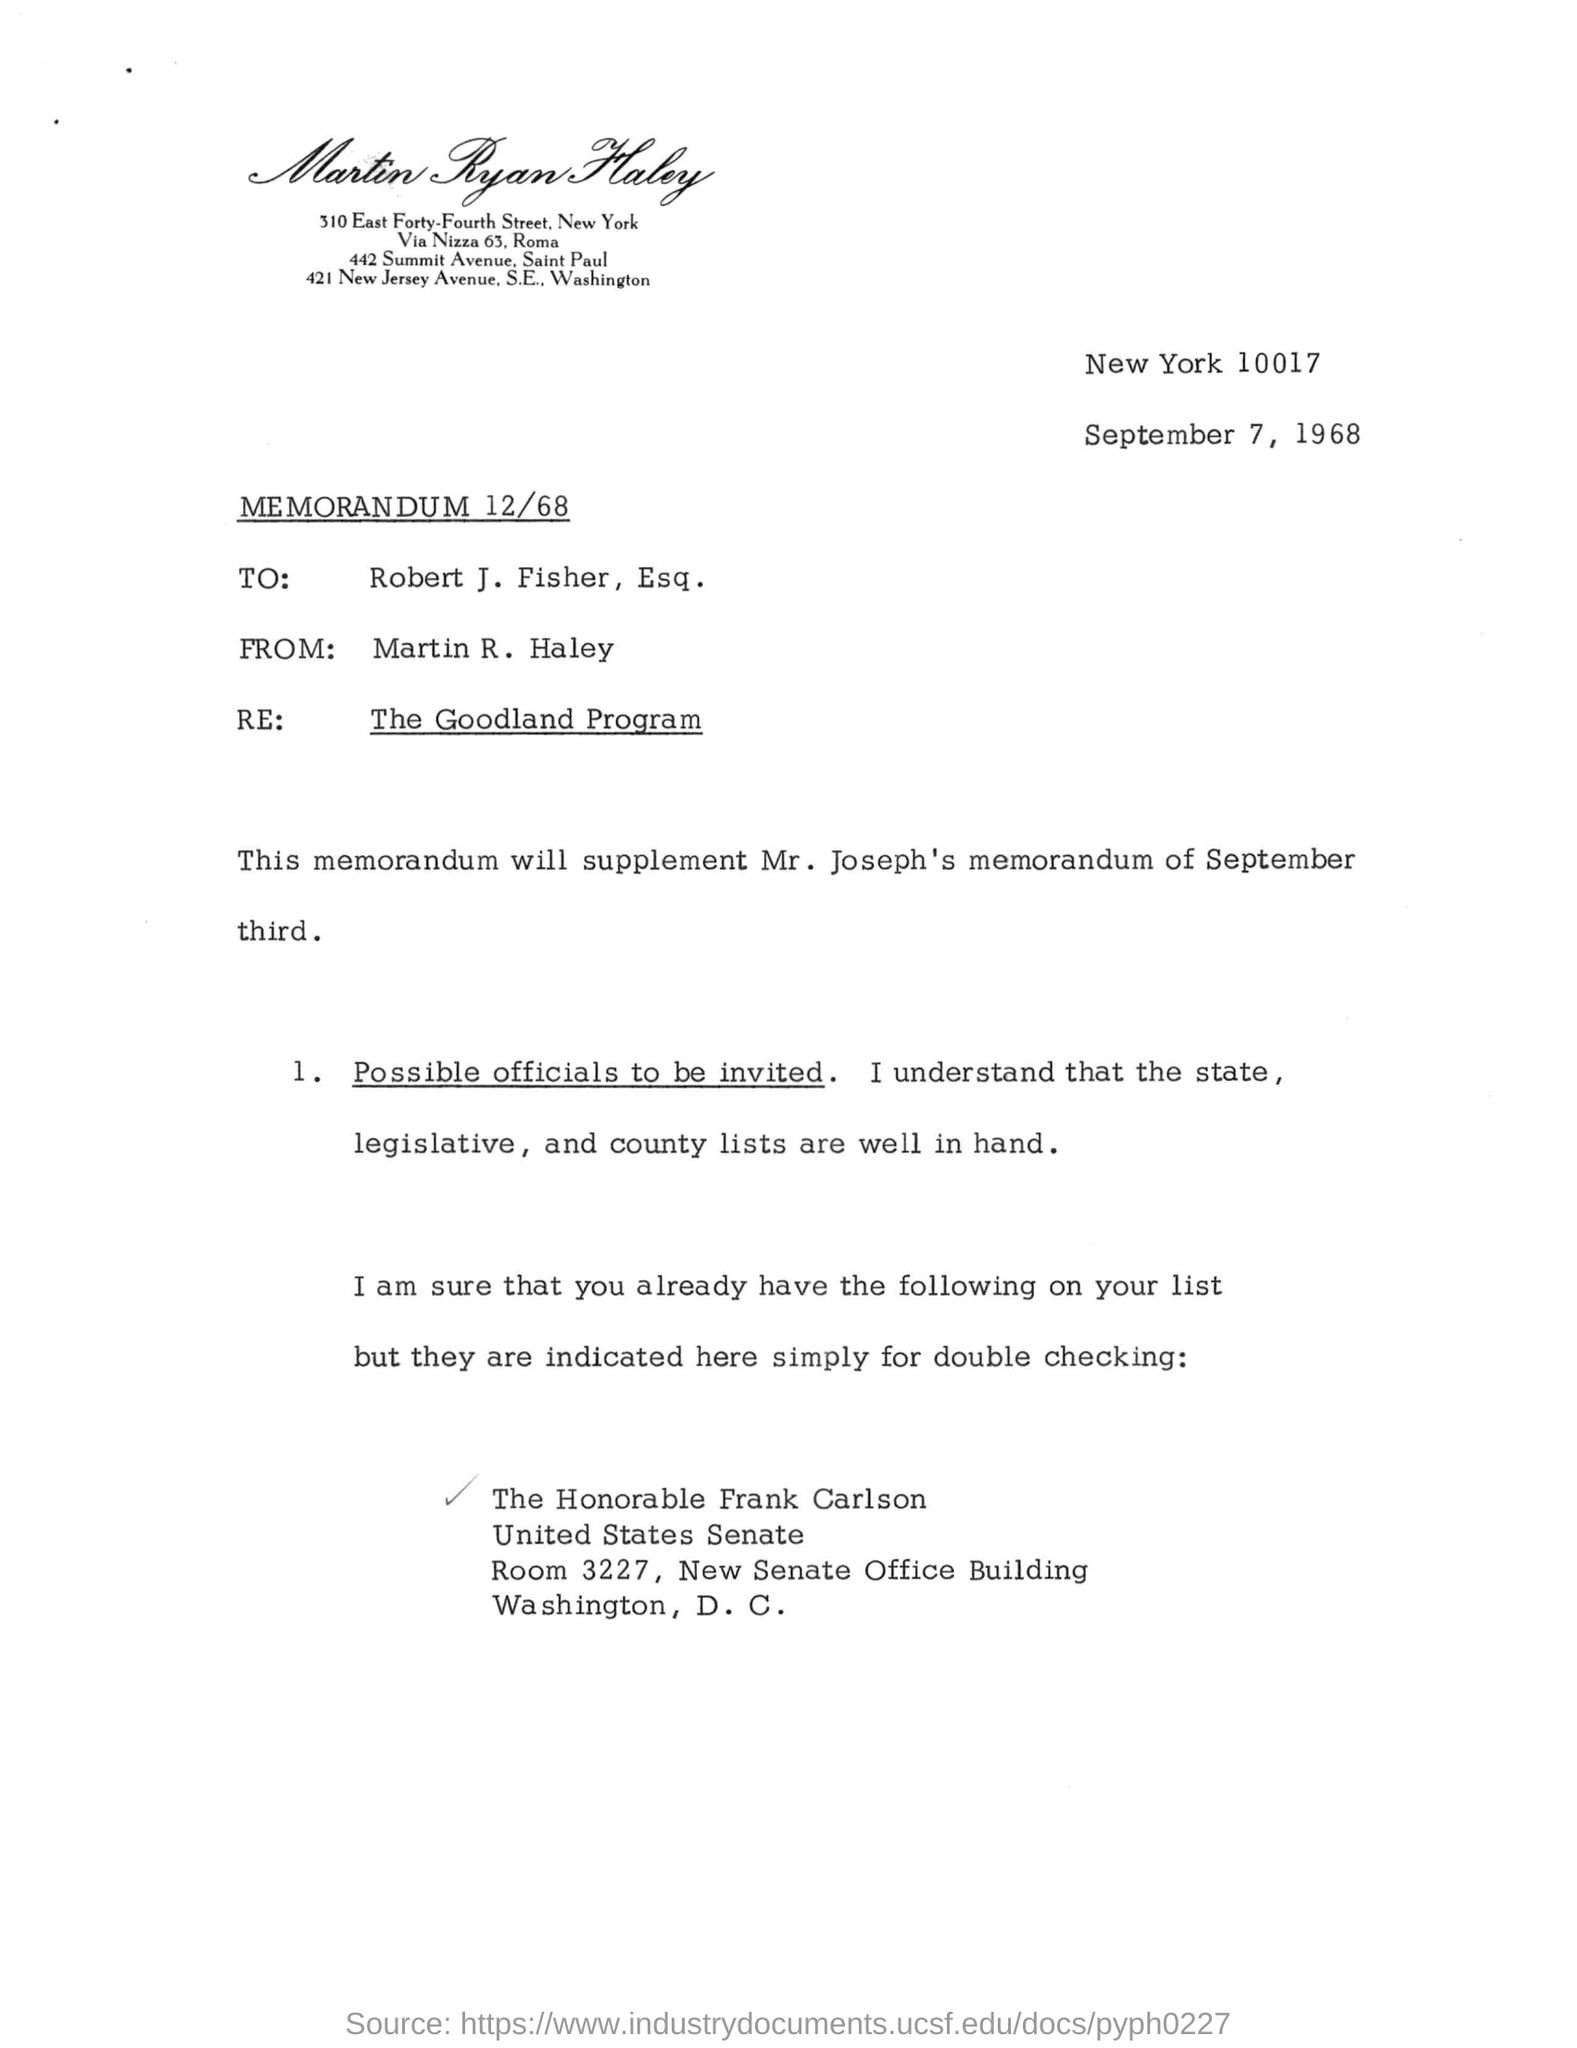What is the title of the document ?
Provide a short and direct response. MEMORANDUM 12/68. What date mentioned on the document ?
Offer a terse response. September 7, 1968. Who sent this ?
Make the answer very short. Martin R . Haley. Who is the recipient ?
Provide a succinct answer. Robert J. Fisher. 